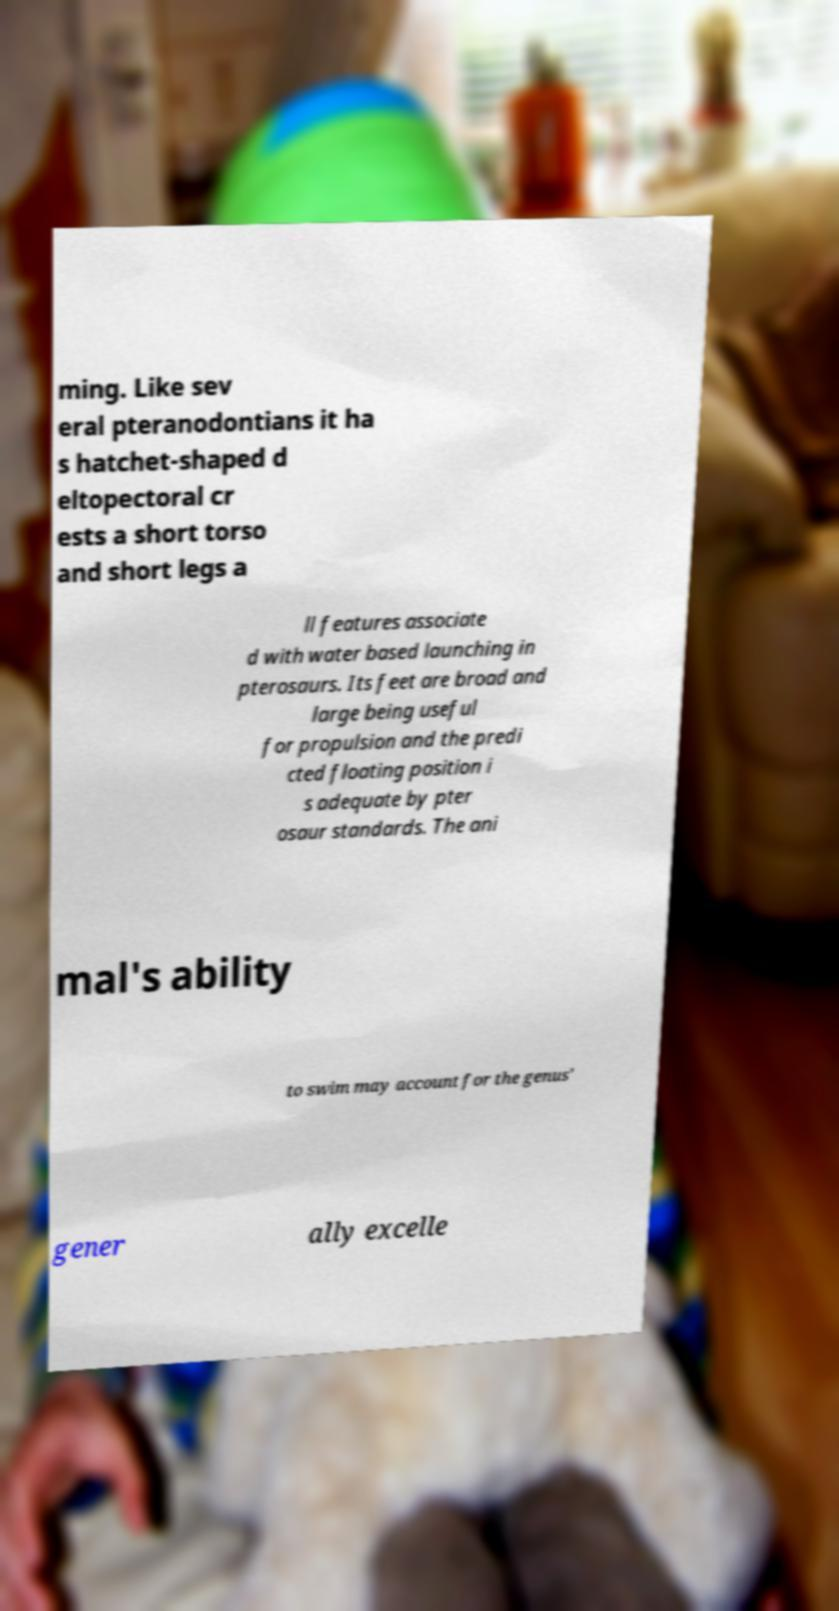I need the written content from this picture converted into text. Can you do that? ming. Like sev eral pteranodontians it ha s hatchet-shaped d eltopectoral cr ests a short torso and short legs a ll features associate d with water based launching in pterosaurs. Its feet are broad and large being useful for propulsion and the predi cted floating position i s adequate by pter osaur standards. The ani mal's ability to swim may account for the genus' gener ally excelle 